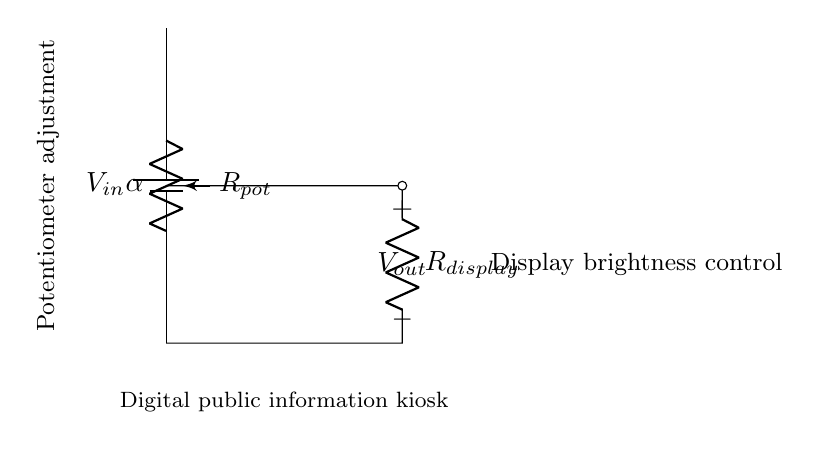What is the input voltage in this circuit? The circuit diagram indicates an input voltage labeled as V_in, but does not specify its numerical value. However, it represents the voltage applied to the circuit.
Answer: V_in What component is used to adjust the output voltage? The potentiometer labeled R_pot is the component used to adjust the voltage output by varying its resistance. This adjustment allows control over the display brightness.
Answer: Potentiometer What is the purpose of the resistor labeled R_display? R_display is connected in series with the output and serves to limit the current to the display, effectively controlling its brightness based on the voltage divider effect.
Answer: Current limiting What is the connection type between R_pot and R_display? R_pot and R_display are connected in series, meaning their resistances add up, and the voltage output is taken from the junction between them. This is characteristic of a voltage divider setup.
Answer: Series How does adjusting the potentiometer affect V_out? Adjusting the potentiometer changes the resistance in the voltage divider, thereby altering the voltage output (V_out) based on the voltage divider formula, which impacts display brightness.
Answer: Changes V_out What happens to the display bright when R_pot is at its minimum resistance? When the potentiometer is at its minimum resistance, most of the input voltage is dropped across R_display, leading to maximum brightness of the display.
Answer: Maximum brightness What type of circuit configuration is used in this diagram? The circuit configuration shown is a voltage divider, which utilizes a potentiometer to adjust voltage levels for controlling brightness within electronic circuits.
Answer: Voltage divider 